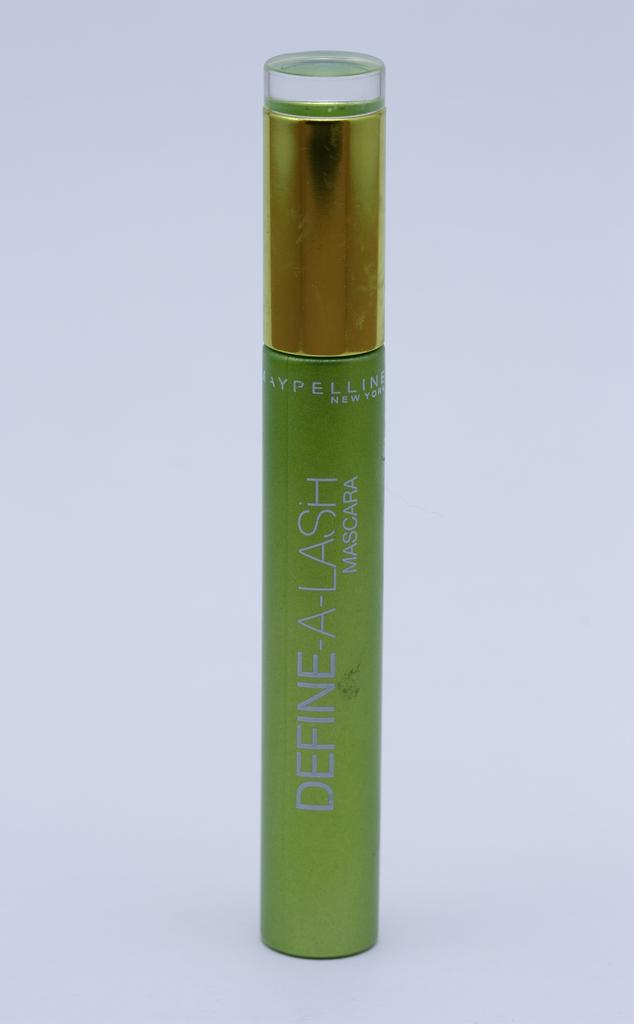What type of items are present in the image? There are cosmetics in the image. What color is the background of the image? The background of the image is white. What size of pancake is being used to apply the cosmetics in the image? There is no pancake present in the image, and cosmetics are not typically applied with pancakes. 